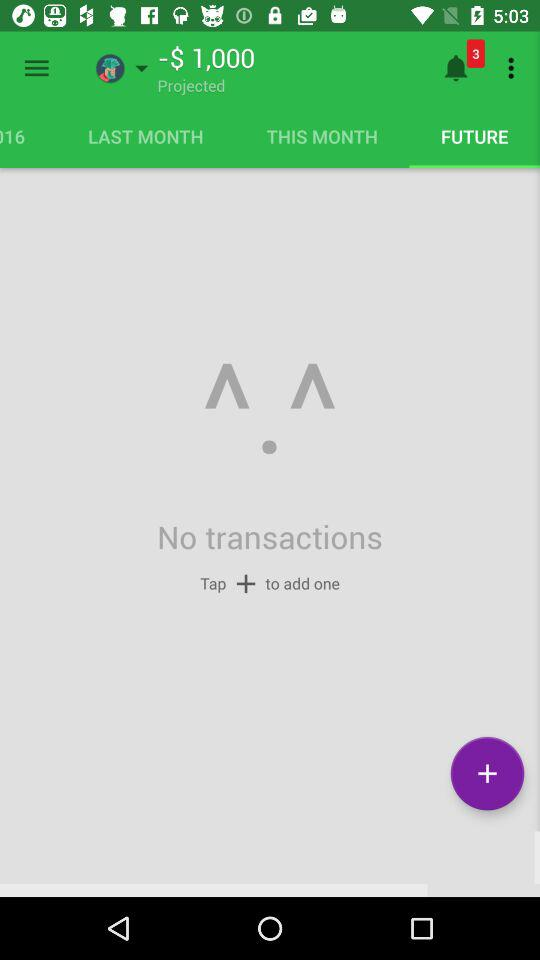How many notifications? There are 3 notifications. 